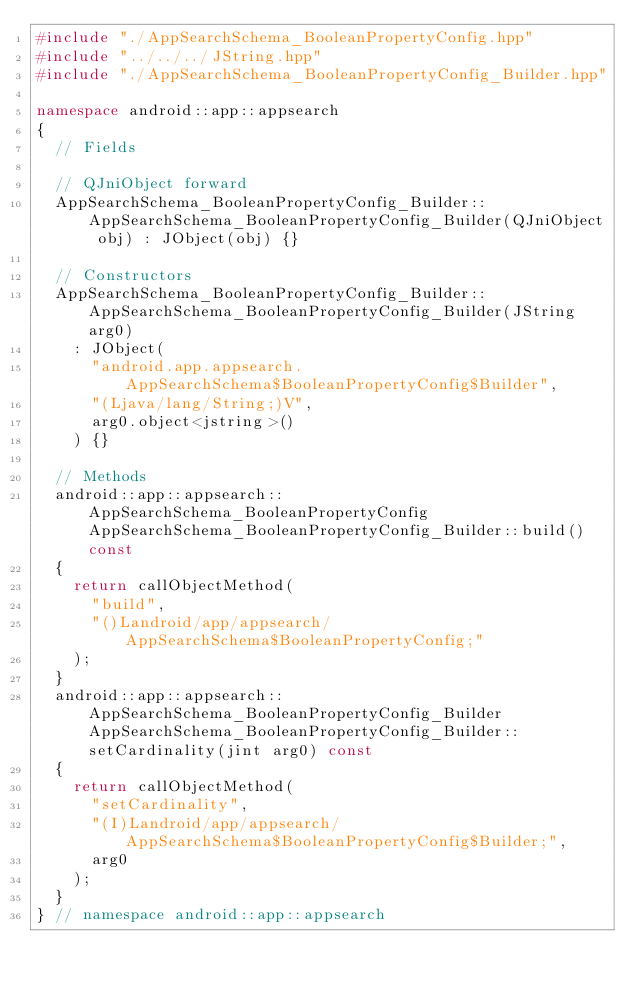<code> <loc_0><loc_0><loc_500><loc_500><_C++_>#include "./AppSearchSchema_BooleanPropertyConfig.hpp"
#include "../../../JString.hpp"
#include "./AppSearchSchema_BooleanPropertyConfig_Builder.hpp"

namespace android::app::appsearch
{
	// Fields
	
	// QJniObject forward
	AppSearchSchema_BooleanPropertyConfig_Builder::AppSearchSchema_BooleanPropertyConfig_Builder(QJniObject obj) : JObject(obj) {}
	
	// Constructors
	AppSearchSchema_BooleanPropertyConfig_Builder::AppSearchSchema_BooleanPropertyConfig_Builder(JString arg0)
		: JObject(
			"android.app.appsearch.AppSearchSchema$BooleanPropertyConfig$Builder",
			"(Ljava/lang/String;)V",
			arg0.object<jstring>()
		) {}
	
	// Methods
	android::app::appsearch::AppSearchSchema_BooleanPropertyConfig AppSearchSchema_BooleanPropertyConfig_Builder::build() const
	{
		return callObjectMethod(
			"build",
			"()Landroid/app/appsearch/AppSearchSchema$BooleanPropertyConfig;"
		);
	}
	android::app::appsearch::AppSearchSchema_BooleanPropertyConfig_Builder AppSearchSchema_BooleanPropertyConfig_Builder::setCardinality(jint arg0) const
	{
		return callObjectMethod(
			"setCardinality",
			"(I)Landroid/app/appsearch/AppSearchSchema$BooleanPropertyConfig$Builder;",
			arg0
		);
	}
} // namespace android::app::appsearch

</code> 